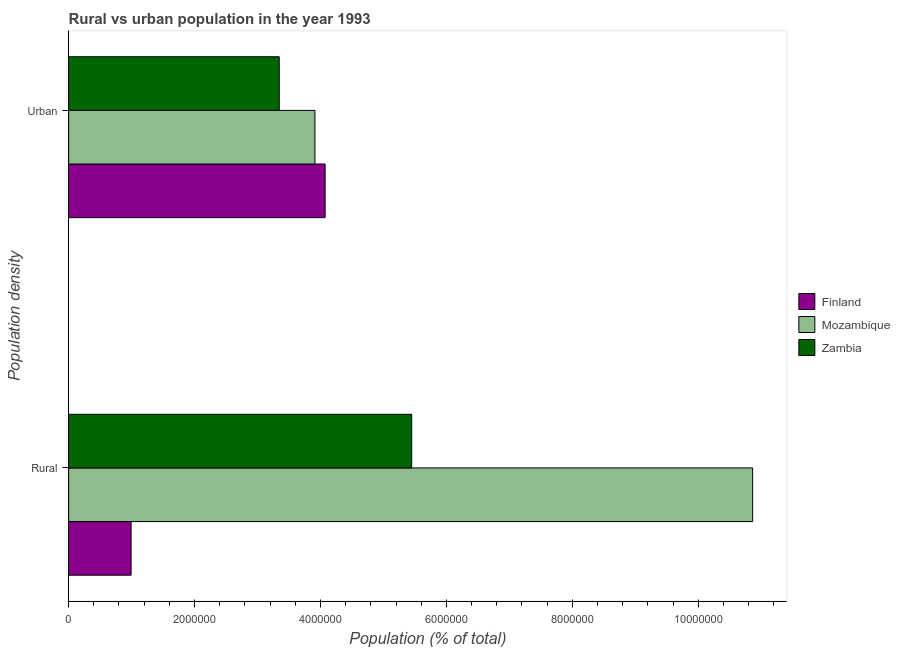Are the number of bars per tick equal to the number of legend labels?
Provide a succinct answer. Yes. How many bars are there on the 2nd tick from the top?
Your response must be concise. 3. What is the label of the 2nd group of bars from the top?
Ensure brevity in your answer.  Rural. What is the rural population density in Mozambique?
Offer a terse response. 1.09e+07. Across all countries, what is the maximum urban population density?
Ensure brevity in your answer.  4.07e+06. Across all countries, what is the minimum rural population density?
Provide a short and direct response. 9.93e+05. In which country was the rural population density maximum?
Offer a very short reply. Mozambique. In which country was the urban population density minimum?
Your answer should be compact. Zambia. What is the total urban population density in the graph?
Your answer should be compact. 1.13e+07. What is the difference between the urban population density in Finland and that in Zambia?
Give a very brief answer. 7.28e+05. What is the difference between the urban population density in Mozambique and the rural population density in Zambia?
Your response must be concise. -1.54e+06. What is the average urban population density per country?
Your answer should be compact. 3.78e+06. What is the difference between the rural population density and urban population density in Finland?
Make the answer very short. -3.08e+06. What is the ratio of the rural population density in Mozambique to that in Finland?
Provide a short and direct response. 10.94. In how many countries, is the rural population density greater than the average rural population density taken over all countries?
Ensure brevity in your answer.  1. How many bars are there?
Make the answer very short. 6. Does the graph contain any zero values?
Offer a very short reply. No. Does the graph contain grids?
Provide a short and direct response. No. How are the legend labels stacked?
Keep it short and to the point. Vertical. What is the title of the graph?
Give a very brief answer. Rural vs urban population in the year 1993. Does "Latvia" appear as one of the legend labels in the graph?
Provide a succinct answer. No. What is the label or title of the X-axis?
Provide a succinct answer. Population (% of total). What is the label or title of the Y-axis?
Your answer should be very brief. Population density. What is the Population (% of total) in Finland in Rural?
Your answer should be very brief. 9.93e+05. What is the Population (% of total) of Mozambique in Rural?
Offer a very short reply. 1.09e+07. What is the Population (% of total) in Zambia in Rural?
Offer a very short reply. 5.45e+06. What is the Population (% of total) of Finland in Urban?
Your answer should be compact. 4.07e+06. What is the Population (% of total) in Mozambique in Urban?
Keep it short and to the point. 3.91e+06. What is the Population (% of total) in Zambia in Urban?
Offer a terse response. 3.35e+06. Across all Population density, what is the maximum Population (% of total) in Finland?
Your answer should be very brief. 4.07e+06. Across all Population density, what is the maximum Population (% of total) in Mozambique?
Your answer should be very brief. 1.09e+07. Across all Population density, what is the maximum Population (% of total) of Zambia?
Keep it short and to the point. 5.45e+06. Across all Population density, what is the minimum Population (% of total) in Finland?
Provide a short and direct response. 9.93e+05. Across all Population density, what is the minimum Population (% of total) in Mozambique?
Give a very brief answer. 3.91e+06. Across all Population density, what is the minimum Population (% of total) in Zambia?
Offer a terse response. 3.35e+06. What is the total Population (% of total) in Finland in the graph?
Offer a very short reply. 5.07e+06. What is the total Population (% of total) in Mozambique in the graph?
Give a very brief answer. 1.48e+07. What is the total Population (% of total) of Zambia in the graph?
Offer a terse response. 8.79e+06. What is the difference between the Population (% of total) of Finland in Rural and that in Urban?
Provide a short and direct response. -3.08e+06. What is the difference between the Population (% of total) in Mozambique in Rural and that in Urban?
Offer a terse response. 6.95e+06. What is the difference between the Population (% of total) of Zambia in Rural and that in Urban?
Provide a succinct answer. 2.10e+06. What is the difference between the Population (% of total) of Finland in Rural and the Population (% of total) of Mozambique in Urban?
Offer a very short reply. -2.92e+06. What is the difference between the Population (% of total) of Finland in Rural and the Population (% of total) of Zambia in Urban?
Your response must be concise. -2.35e+06. What is the difference between the Population (% of total) of Mozambique in Rural and the Population (% of total) of Zambia in Urban?
Provide a short and direct response. 7.52e+06. What is the average Population (% of total) in Finland per Population density?
Keep it short and to the point. 2.53e+06. What is the average Population (% of total) in Mozambique per Population density?
Ensure brevity in your answer.  7.39e+06. What is the average Population (% of total) of Zambia per Population density?
Your response must be concise. 4.40e+06. What is the difference between the Population (% of total) of Finland and Population (% of total) of Mozambique in Rural?
Offer a terse response. -9.87e+06. What is the difference between the Population (% of total) in Finland and Population (% of total) in Zambia in Rural?
Provide a short and direct response. -4.46e+06. What is the difference between the Population (% of total) of Mozambique and Population (% of total) of Zambia in Rural?
Ensure brevity in your answer.  5.41e+06. What is the difference between the Population (% of total) of Finland and Population (% of total) of Mozambique in Urban?
Give a very brief answer. 1.61e+05. What is the difference between the Population (% of total) in Finland and Population (% of total) in Zambia in Urban?
Make the answer very short. 7.28e+05. What is the difference between the Population (% of total) of Mozambique and Population (% of total) of Zambia in Urban?
Offer a very short reply. 5.67e+05. What is the ratio of the Population (% of total) of Finland in Rural to that in Urban?
Provide a succinct answer. 0.24. What is the ratio of the Population (% of total) of Mozambique in Rural to that in Urban?
Provide a short and direct response. 2.78. What is the ratio of the Population (% of total) of Zambia in Rural to that in Urban?
Your answer should be very brief. 1.63. What is the difference between the highest and the second highest Population (% of total) of Finland?
Provide a succinct answer. 3.08e+06. What is the difference between the highest and the second highest Population (% of total) of Mozambique?
Provide a short and direct response. 6.95e+06. What is the difference between the highest and the second highest Population (% of total) of Zambia?
Ensure brevity in your answer.  2.10e+06. What is the difference between the highest and the lowest Population (% of total) of Finland?
Make the answer very short. 3.08e+06. What is the difference between the highest and the lowest Population (% of total) in Mozambique?
Offer a very short reply. 6.95e+06. What is the difference between the highest and the lowest Population (% of total) of Zambia?
Keep it short and to the point. 2.10e+06. 